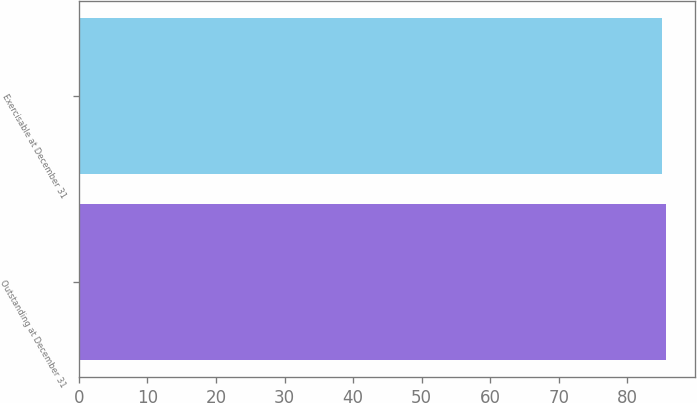<chart> <loc_0><loc_0><loc_500><loc_500><bar_chart><fcel>Outstanding at December 31<fcel>Exercisable at December 31<nl><fcel>85.61<fcel>85.03<nl></chart> 